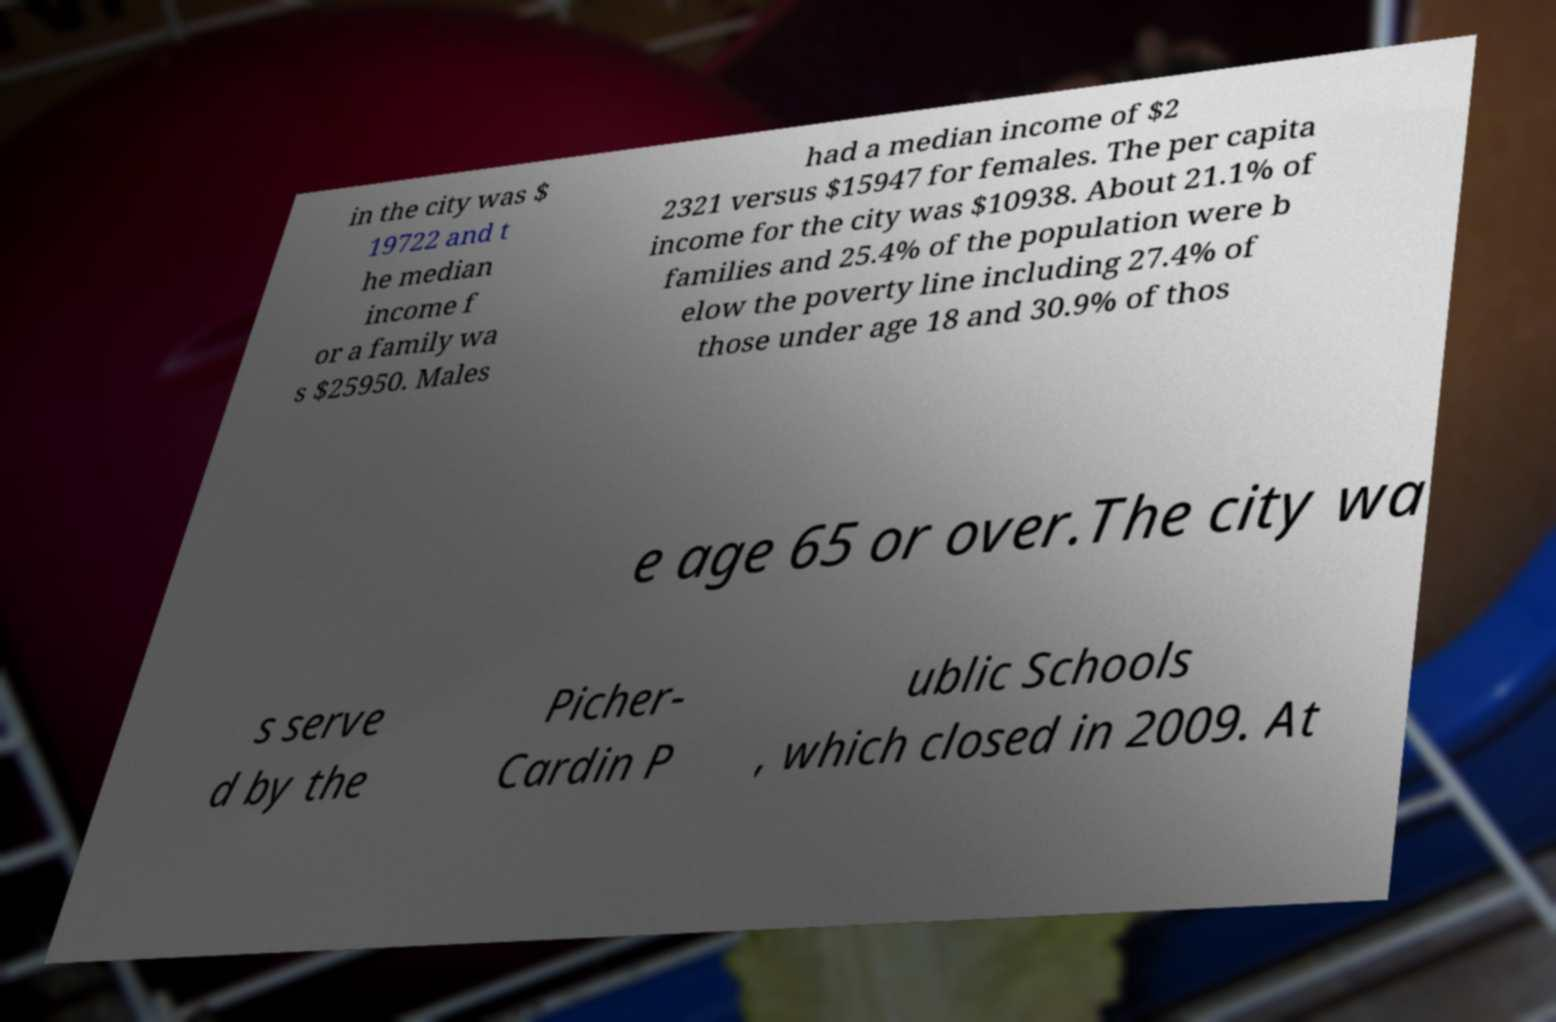What messages or text are displayed in this image? I need them in a readable, typed format. in the city was $ 19722 and t he median income f or a family wa s $25950. Males had a median income of $2 2321 versus $15947 for females. The per capita income for the city was $10938. About 21.1% of families and 25.4% of the population were b elow the poverty line including 27.4% of those under age 18 and 30.9% of thos e age 65 or over.The city wa s serve d by the Picher- Cardin P ublic Schools , which closed in 2009. At 